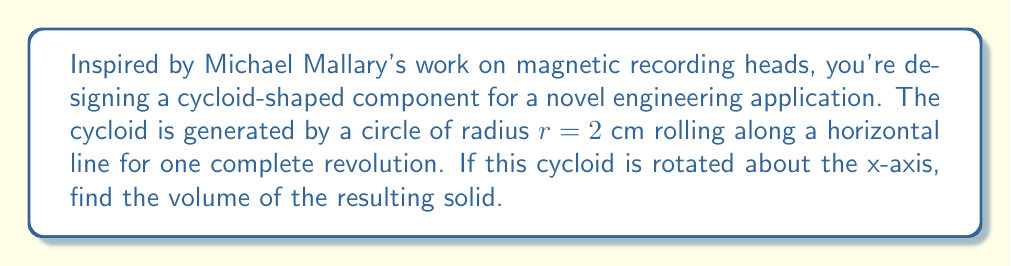Could you help me with this problem? Let's approach this step-by-step:

1) The parametric equations for a cycloid are:
   $x = r(t - \sin t)$
   $y = r(1 - \cos t)$
   where $0 \leq t \leq 2\pi$

2) To find the volume of a solid formed by rotating a curve around the x-axis, we use the washer method:
   $V = \pi \int_a^b [f(x)]^2 dx$

3) However, our curve is in parametric form. We need to convert this to:
   $V = \pi \int_0^{2\pi} y^2 \frac{dx}{dt} dt$

4) Substituting our equations and $r = 2$:
   $x = 2(t - \sin t)$
   $y = 2(1 - \cos t)$

5) We need $\frac{dx}{dt}$:
   $\frac{dx}{dt} = 2(1 - \cos t)$

6) Now we can set up our integral:
   $V = \pi \int_0^{2\pi} [2(1 - \cos t)]^2 \cdot 2(1 - \cos t) dt$
   $= 8\pi \int_0^{2\pi} (1 - \cos t)^3 dt$

7) Expand $(1 - \cos t)^3$:
   $(1 - \cos t)^3 = 1 - 3\cos t + 3\cos^2 t - \cos^3 t$

8) Our integral becomes:
   $V = 8\pi \int_0^{2\pi} (1 - 3\cos t + 3\cos^2 t - \cos^3 t) dt$

9) Integrate term by term:
   $\int_0^{2\pi} 1 dt = 2\pi$
   $\int_0^{2\pi} \cos t dt = 0$
   $\int_0^{2\pi} \cos^2 t dt = \pi$
   $\int_0^{2\pi} \cos^3 t dt = 0$

10) Substituting back:
    $V = 8\pi [2\pi - 0 + 3\pi - 0] = 40\pi^2$ cm³
Answer: The volume of the solid formed by rotating the cycloid about the x-axis is $40\pi^2$ cm³. 